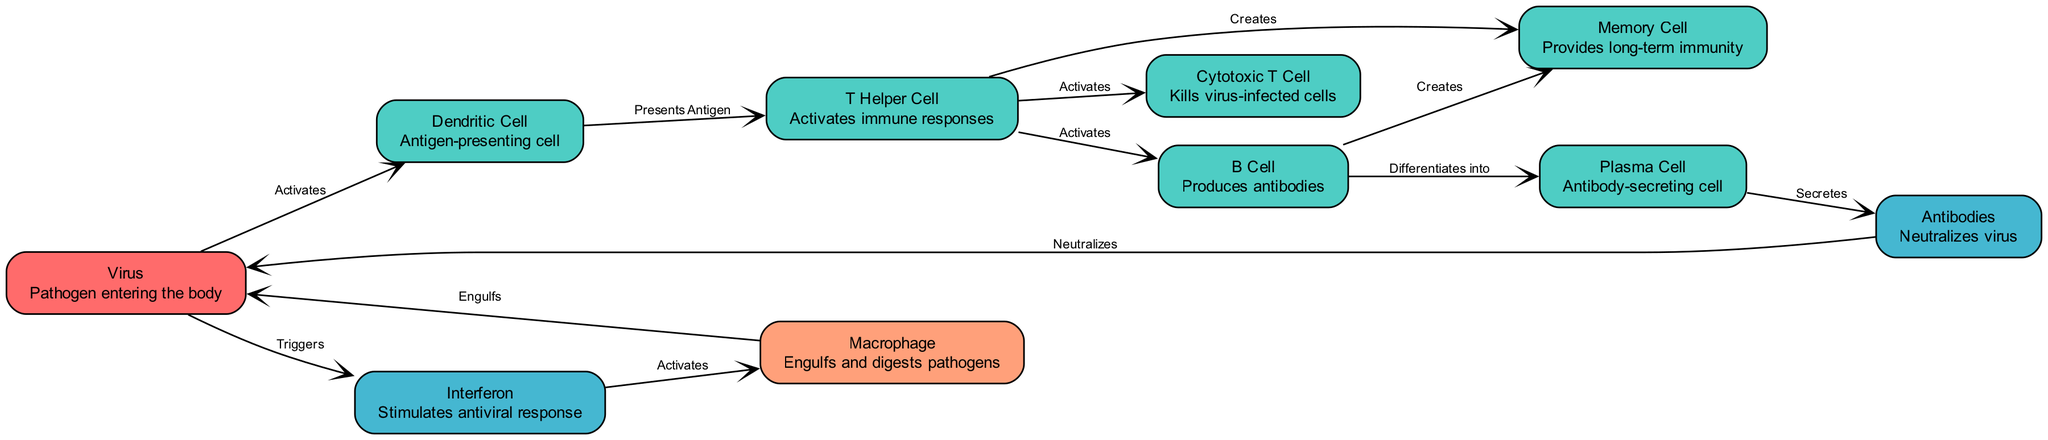What is the immune cell that presents antigens? The diagram illustrates that the Dendritic Cell presents antigens to T Helper Cells as part of the immune response mechanism.
Answer: Dendritic Cell How many types of antibodies are mentioned in the diagram? The diagram specifically identifies one type of antibody, referred to simply as Antibodies, synthesized by Plasma Cells.
Answer: One What cell type is responsible for killing virus-infected cells? By examining the diagram, we see that the Cytotoxic T Cell is designated as the immune cell that directly kills virus-infected cells following activation by T Helper Cells.
Answer: Cytotoxic T Cell Which cell type produces the antibodies? The diagram shows that B Cells differentiate into Plasma Cells, which are the ones that secrete antibodies in response to viral infections.
Answer: Plasma Cell What triggers the activation of macrophages? According to the diagram, the presence of the virus triggers the production of Interferon, which subsequently activates macrophages to fight the infection.
Answer: Interferon How many memory cell types are generated from T Helper Cells and B Cells? The diagram indicates that both T Helper Cells and B Cells contribute to the creation of Memory Cells, suggesting there are at least two pathways for their generation.
Answer: Two What role do antibodies play in relation to the virus? In the diagram, antibodies are shown to neutralize the virus, indicating their critical role in inhibiting the virus's effects during an infection.
Answer: Neutralizes What is the initial interaction shown in the diagram? The diagram starts with the Virus, which activates the Dendritic Cell, establishing the immune defense mechanism.
Answer: Virus activates Dendritic Cell Which immune cell is responsible for engulfing pathogens? The diagram explicitly identifies the Macrophage as the immune cell that engulfs and digests pathogens, playing a key role in the immune response.
Answer: Macrophage 